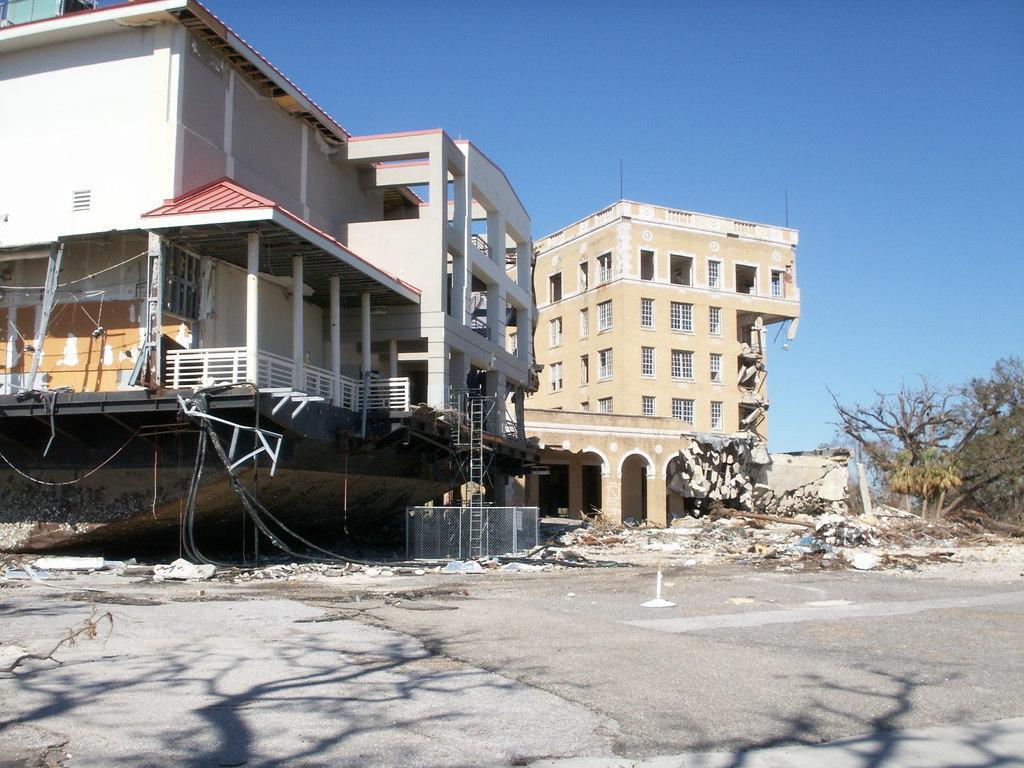In one or two sentences, can you explain what this image depicts? In this image there are buildings. One of the building is in renovation. There are trees on the right side. There is a sky. There is a road. 